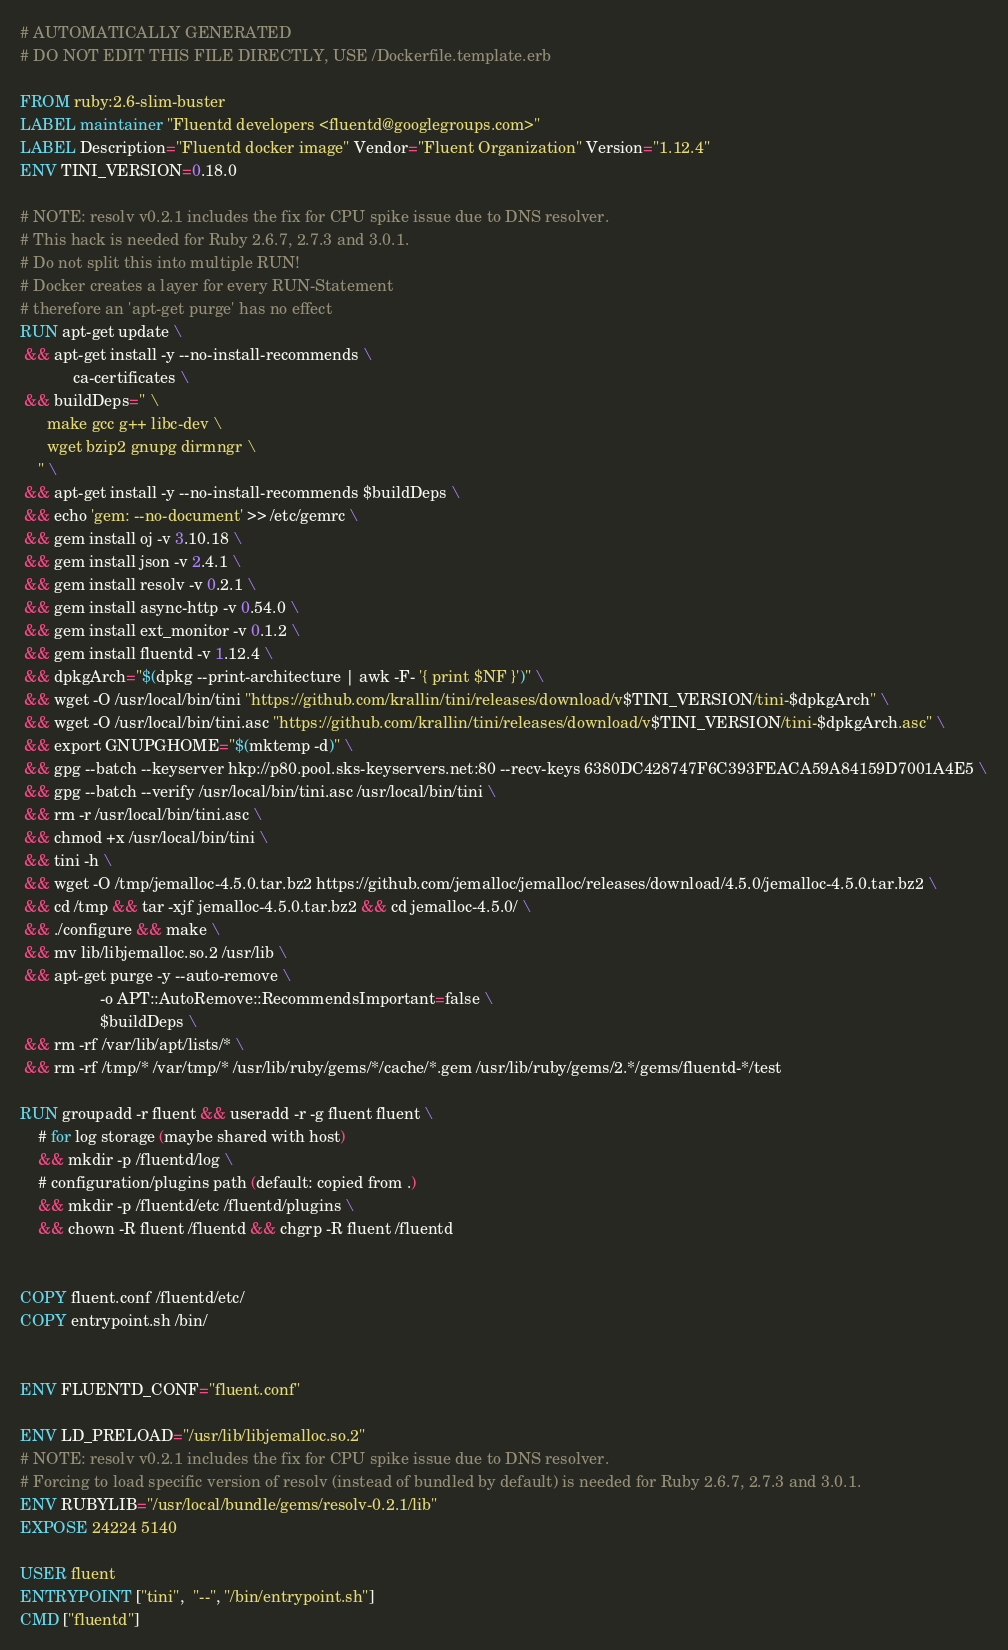Convert code to text. <code><loc_0><loc_0><loc_500><loc_500><_Dockerfile_># AUTOMATICALLY GENERATED
# DO NOT EDIT THIS FILE DIRECTLY, USE /Dockerfile.template.erb

FROM ruby:2.6-slim-buster
LABEL maintainer "Fluentd developers <fluentd@googlegroups.com>"
LABEL Description="Fluentd docker image" Vendor="Fluent Organization" Version="1.12.4"
ENV TINI_VERSION=0.18.0

# NOTE: resolv v0.2.1 includes the fix for CPU spike issue due to DNS resolver.
# This hack is needed for Ruby 2.6.7, 2.7.3 and 3.0.1.
# Do not split this into multiple RUN!
# Docker creates a layer for every RUN-Statement
# therefore an 'apt-get purge' has no effect
RUN apt-get update \
 && apt-get install -y --no-install-recommends \
            ca-certificates \
 && buildDeps=" \
      make gcc g++ libc-dev \
      wget bzip2 gnupg dirmngr \
    " \
 && apt-get install -y --no-install-recommends $buildDeps \
 && echo 'gem: --no-document' >> /etc/gemrc \
 && gem install oj -v 3.10.18 \
 && gem install json -v 2.4.1 \
 && gem install resolv -v 0.2.1 \
 && gem install async-http -v 0.54.0 \
 && gem install ext_monitor -v 0.1.2 \
 && gem install fluentd -v 1.12.4 \
 && dpkgArch="$(dpkg --print-architecture | awk -F- '{ print $NF }')" \
 && wget -O /usr/local/bin/tini "https://github.com/krallin/tini/releases/download/v$TINI_VERSION/tini-$dpkgArch" \
 && wget -O /usr/local/bin/tini.asc "https://github.com/krallin/tini/releases/download/v$TINI_VERSION/tini-$dpkgArch.asc" \
 && export GNUPGHOME="$(mktemp -d)" \
 && gpg --batch --keyserver hkp://p80.pool.sks-keyservers.net:80 --recv-keys 6380DC428747F6C393FEACA59A84159D7001A4E5 \
 && gpg --batch --verify /usr/local/bin/tini.asc /usr/local/bin/tini \
 && rm -r /usr/local/bin/tini.asc \
 && chmod +x /usr/local/bin/tini \
 && tini -h \
 && wget -O /tmp/jemalloc-4.5.0.tar.bz2 https://github.com/jemalloc/jemalloc/releases/download/4.5.0/jemalloc-4.5.0.tar.bz2 \
 && cd /tmp && tar -xjf jemalloc-4.5.0.tar.bz2 && cd jemalloc-4.5.0/ \
 && ./configure && make \
 && mv lib/libjemalloc.so.2 /usr/lib \
 && apt-get purge -y --auto-remove \
                  -o APT::AutoRemove::RecommendsImportant=false \
                  $buildDeps \
 && rm -rf /var/lib/apt/lists/* \
 && rm -rf /tmp/* /var/tmp/* /usr/lib/ruby/gems/*/cache/*.gem /usr/lib/ruby/gems/2.*/gems/fluentd-*/test

RUN groupadd -r fluent && useradd -r -g fluent fluent \
    # for log storage (maybe shared with host)
    && mkdir -p /fluentd/log \
    # configuration/plugins path (default: copied from .)
    && mkdir -p /fluentd/etc /fluentd/plugins \
    && chown -R fluent /fluentd && chgrp -R fluent /fluentd


COPY fluent.conf /fluentd/etc/
COPY entrypoint.sh /bin/


ENV FLUENTD_CONF="fluent.conf"

ENV LD_PRELOAD="/usr/lib/libjemalloc.so.2"
# NOTE: resolv v0.2.1 includes the fix for CPU spike issue due to DNS resolver.
# Forcing to load specific version of resolv (instead of bundled by default) is needed for Ruby 2.6.7, 2.7.3 and 3.0.1.
ENV RUBYLIB="/usr/local/bundle/gems/resolv-0.2.1/lib"
EXPOSE 24224 5140

USER fluent
ENTRYPOINT ["tini",  "--", "/bin/entrypoint.sh"]
CMD ["fluentd"]

</code> 